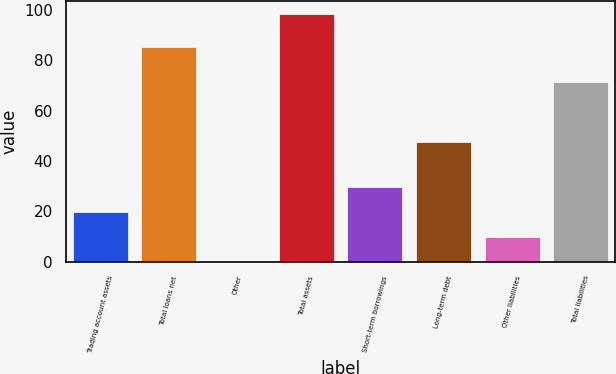Convert chart. <chart><loc_0><loc_0><loc_500><loc_500><bar_chart><fcel>Trading account assets<fcel>Total loans net<fcel>Other<fcel>Total assets<fcel>Short-term borrowings<fcel>Long-term debt<fcel>Other liabilities<fcel>Total liabilities<nl><fcel>19.76<fcel>85.3<fcel>0.1<fcel>98.4<fcel>29.59<fcel>47.6<fcel>9.93<fcel>71.3<nl></chart> 